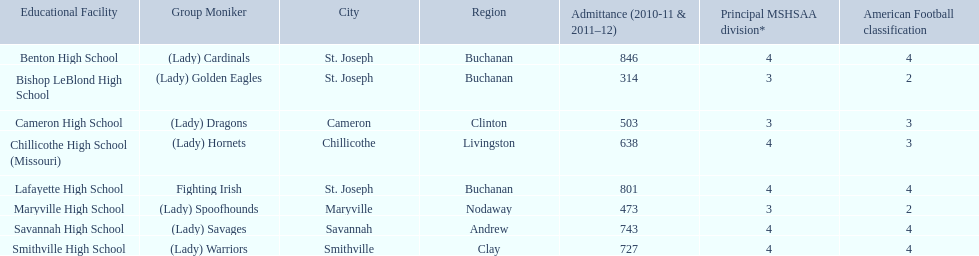What school in midland empire conference has 846 students enrolled? Benton High School. What school has 314 students enrolled? Bishop LeBlond High School. What school had 638 students enrolled? Chillicothe High School (Missouri). 